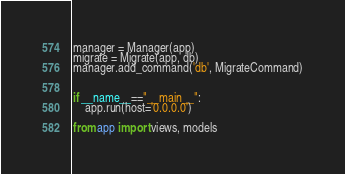Convert code to text. <code><loc_0><loc_0><loc_500><loc_500><_Python_>manager = Manager(app)
migrate = Migrate(app, db)
manager.add_command('db', MigrateCommand)


if __name__=="__main__":
	app.run(host='0.0.0.0')

from app import views, models</code> 